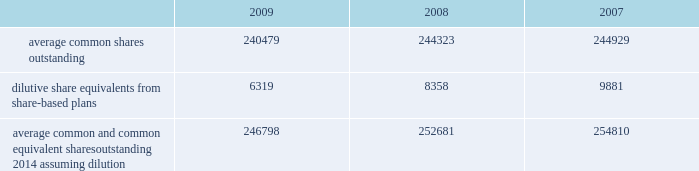The company has a restricted stock plan for non-employee directors which reserves for issuance of 300000 shares of the company 2019s common stock .
No restricted shares were issued in 2009 .
The company has a directors 2019 deferral plan , which provides a means to defer director compensation , from time to time , on a deferred stock or cash basis .
As of september 30 , 2009 , 86643 shares were held in trust , of which 4356 shares represented directors 2019 compensation in 2009 , in accordance with the provisions of the plan .
Under this plan , which is unfunded , directors have an unsecured contractual commitment from the company .
The company also has a deferred compensation plan that allows certain highly-compensated employees , including executive officers , to defer salary , annual incentive awards and certain equity-based compensation .
As of september 30 , 2009 , 557235 shares were issuable under this plan .
Note 16 2014 earnings per share the weighted average common shares used in the computations of basic and diluted earnings per share ( shares in thousands ) for the years ended september 30 were as follows: .
Average common and common equivalent shares outstanding 2014 assuming dilution .
246798 252681 254810 note 17 2014 segment data the company 2019s organizational structure is based upon its three principal business segments : bd medical ( 201cmedical 201d ) , bd diagnostics ( 201cdiagnostics 201d ) and bd biosciences ( 201cbiosciences 201d ) .
The principal product lines in the medical segment include needles , syringes and intravenous catheters for medication delivery ; safety-engineered and auto-disable devices ; prefilled iv flush syringes ; syringes and pen needles for the self-injection of insulin and other drugs used in the treatment of diabetes ; prefillable drug delivery devices provided to pharmaceutical companies and sold to end-users as drug/device combinations ; surgical blades/scalpels and regional anesthesia needles and trays ; critical care monitoring devices ; ophthalmic surgical instruments ; and sharps disposal containers .
The principal products and services in the diagnostics segment include integrated systems for specimen collection ; an extensive line of safety-engineered specimen blood collection products and systems ; plated media ; automated blood culturing systems ; molecular testing systems for sexually transmitted diseases and healthcare-associated infections ; microorganism identification and drug susceptibility systems ; liquid-based cytology systems for cervical cancer screening ; and rapid diagnostic assays .
The principal product lines in the biosciences segment include fluorescence activated cell sorters and analyzers ; cell imaging systems ; monoclonal antibodies and kits for performing cell analysis ; reagent systems for life sciences research ; tools to aid in drug discovery and growth of tissue and cells ; cell culture media supplements for biopharmaceutical manufacturing ; and diagnostic assays .
The company evaluates performance of its business segments based upon operating income .
Segment operating income represents revenues reduced by product costs and operating expenses .
The company hedges against certain forecasted sales of u.s.-produced products sold outside the united states .
Gains and losses associated with these foreign currency translation hedges are reported in segment revenues based upon their proportionate share of these international sales of u.s.-produced products .
Becton , dickinson and company notes to consolidated financial statements 2014 ( continued ) .
As of september 30 , 2009 what was the percent of the shares were held in trust that represented the directors 2019 compensation in accordance with the provisions of the plan .? 
Computations: (4356 / 86643)
Answer: 0.05028. 